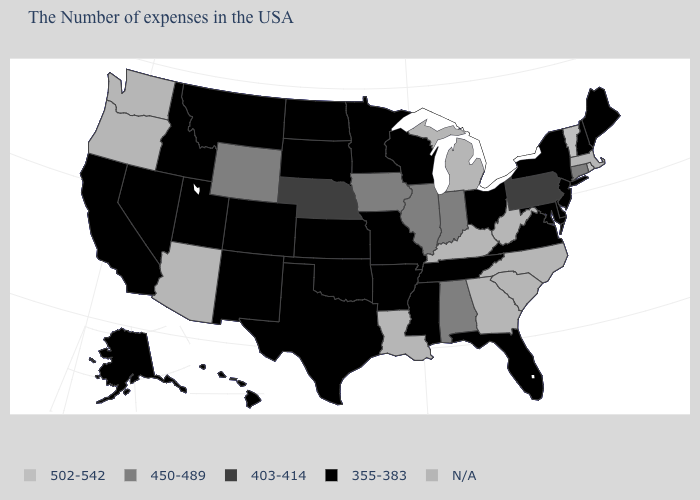What is the value of Mississippi?
Concise answer only. 355-383. Which states have the highest value in the USA?
Short answer required. Rhode Island, Vermont. Name the states that have a value in the range N/A?
Answer briefly. Massachusetts, North Carolina, South Carolina, West Virginia, Georgia, Michigan, Kentucky, Louisiana, Arizona, Washington, Oregon. What is the highest value in the USA?
Answer briefly. 502-542. What is the value of South Carolina?
Concise answer only. N/A. Name the states that have a value in the range 403-414?
Give a very brief answer. Pennsylvania, Nebraska. Name the states that have a value in the range 450-489?
Keep it brief. Connecticut, Indiana, Alabama, Illinois, Iowa, Wyoming. What is the lowest value in the West?
Write a very short answer. 355-383. How many symbols are there in the legend?
Short answer required. 5. Name the states that have a value in the range 355-383?
Answer briefly. Maine, New Hampshire, New York, New Jersey, Delaware, Maryland, Virginia, Ohio, Florida, Tennessee, Wisconsin, Mississippi, Missouri, Arkansas, Minnesota, Kansas, Oklahoma, Texas, South Dakota, North Dakota, Colorado, New Mexico, Utah, Montana, Idaho, Nevada, California, Alaska, Hawaii. Does Vermont have the highest value in the USA?
Keep it brief. Yes. Name the states that have a value in the range 403-414?
Quick response, please. Pennsylvania, Nebraska. What is the value of Utah?
Give a very brief answer. 355-383. Does the first symbol in the legend represent the smallest category?
Be succinct. No. Name the states that have a value in the range 502-542?
Answer briefly. Rhode Island, Vermont. 